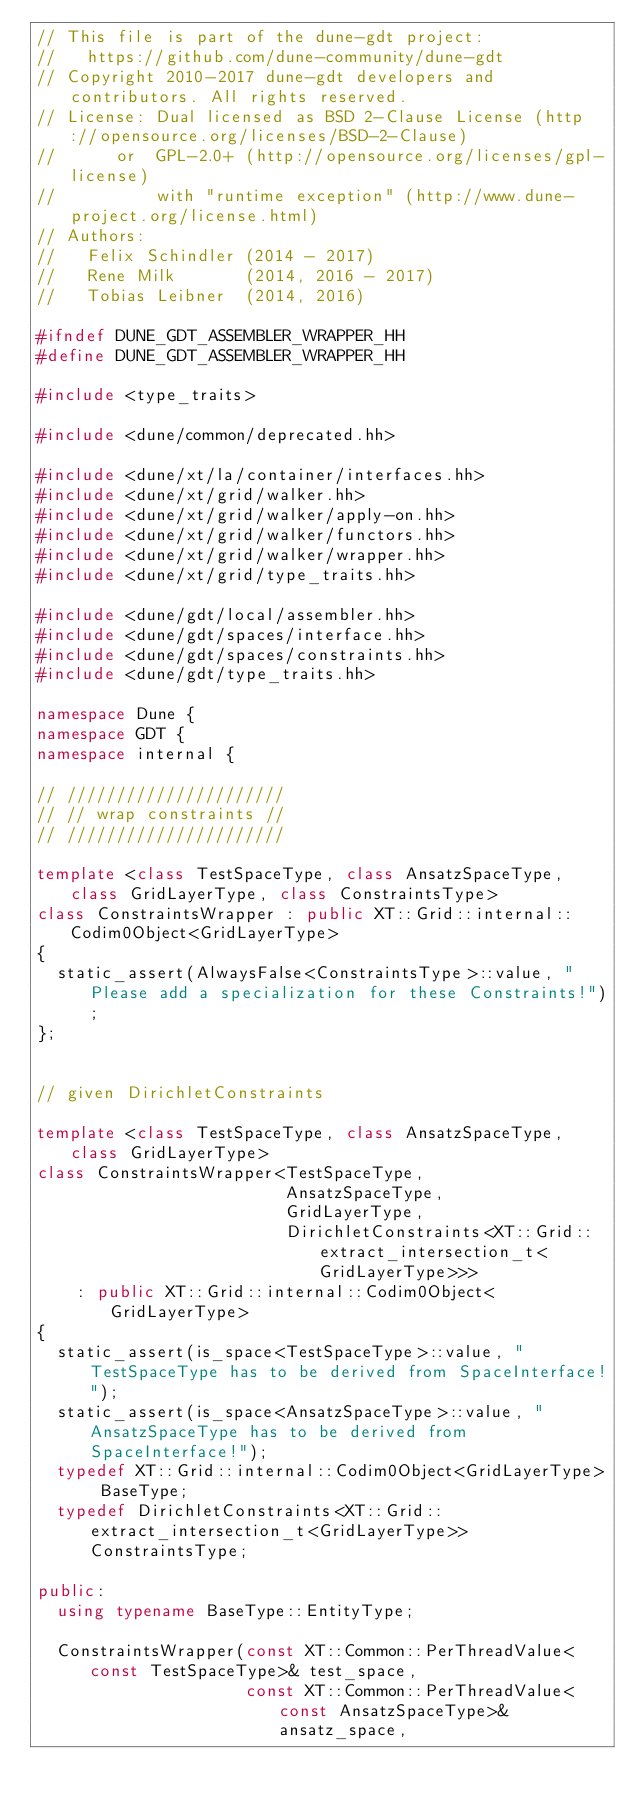Convert code to text. <code><loc_0><loc_0><loc_500><loc_500><_C++_>// This file is part of the dune-gdt project:
//   https://github.com/dune-community/dune-gdt
// Copyright 2010-2017 dune-gdt developers and contributors. All rights reserved.
// License: Dual licensed as BSD 2-Clause License (http://opensource.org/licenses/BSD-2-Clause)
//      or  GPL-2.0+ (http://opensource.org/licenses/gpl-license)
//          with "runtime exception" (http://www.dune-project.org/license.html)
// Authors:
//   Felix Schindler (2014 - 2017)
//   Rene Milk       (2014, 2016 - 2017)
//   Tobias Leibner  (2014, 2016)

#ifndef DUNE_GDT_ASSEMBLER_WRAPPER_HH
#define DUNE_GDT_ASSEMBLER_WRAPPER_HH

#include <type_traits>

#include <dune/common/deprecated.hh>

#include <dune/xt/la/container/interfaces.hh>
#include <dune/xt/grid/walker.hh>
#include <dune/xt/grid/walker/apply-on.hh>
#include <dune/xt/grid/walker/functors.hh>
#include <dune/xt/grid/walker/wrapper.hh>
#include <dune/xt/grid/type_traits.hh>

#include <dune/gdt/local/assembler.hh>
#include <dune/gdt/spaces/interface.hh>
#include <dune/gdt/spaces/constraints.hh>
#include <dune/gdt/type_traits.hh>

namespace Dune {
namespace GDT {
namespace internal {

// //////////////////////
// // wrap constraints //
// //////////////////////

template <class TestSpaceType, class AnsatzSpaceType, class GridLayerType, class ConstraintsType>
class ConstraintsWrapper : public XT::Grid::internal::Codim0Object<GridLayerType>
{
  static_assert(AlwaysFalse<ConstraintsType>::value, "Please add a specialization for these Constraints!");
};


// given DirichletConstraints

template <class TestSpaceType, class AnsatzSpaceType, class GridLayerType>
class ConstraintsWrapper<TestSpaceType,
                         AnsatzSpaceType,
                         GridLayerType,
                         DirichletConstraints<XT::Grid::extract_intersection_t<GridLayerType>>>
    : public XT::Grid::internal::Codim0Object<GridLayerType>
{
  static_assert(is_space<TestSpaceType>::value, "TestSpaceType has to be derived from SpaceInterface!");
  static_assert(is_space<AnsatzSpaceType>::value, "AnsatzSpaceType has to be derived from SpaceInterface!");
  typedef XT::Grid::internal::Codim0Object<GridLayerType> BaseType;
  typedef DirichletConstraints<XT::Grid::extract_intersection_t<GridLayerType>> ConstraintsType;

public:
  using typename BaseType::EntityType;

  ConstraintsWrapper(const XT::Common::PerThreadValue<const TestSpaceType>& test_space,
                     const XT::Common::PerThreadValue<const AnsatzSpaceType>& ansatz_space,</code> 